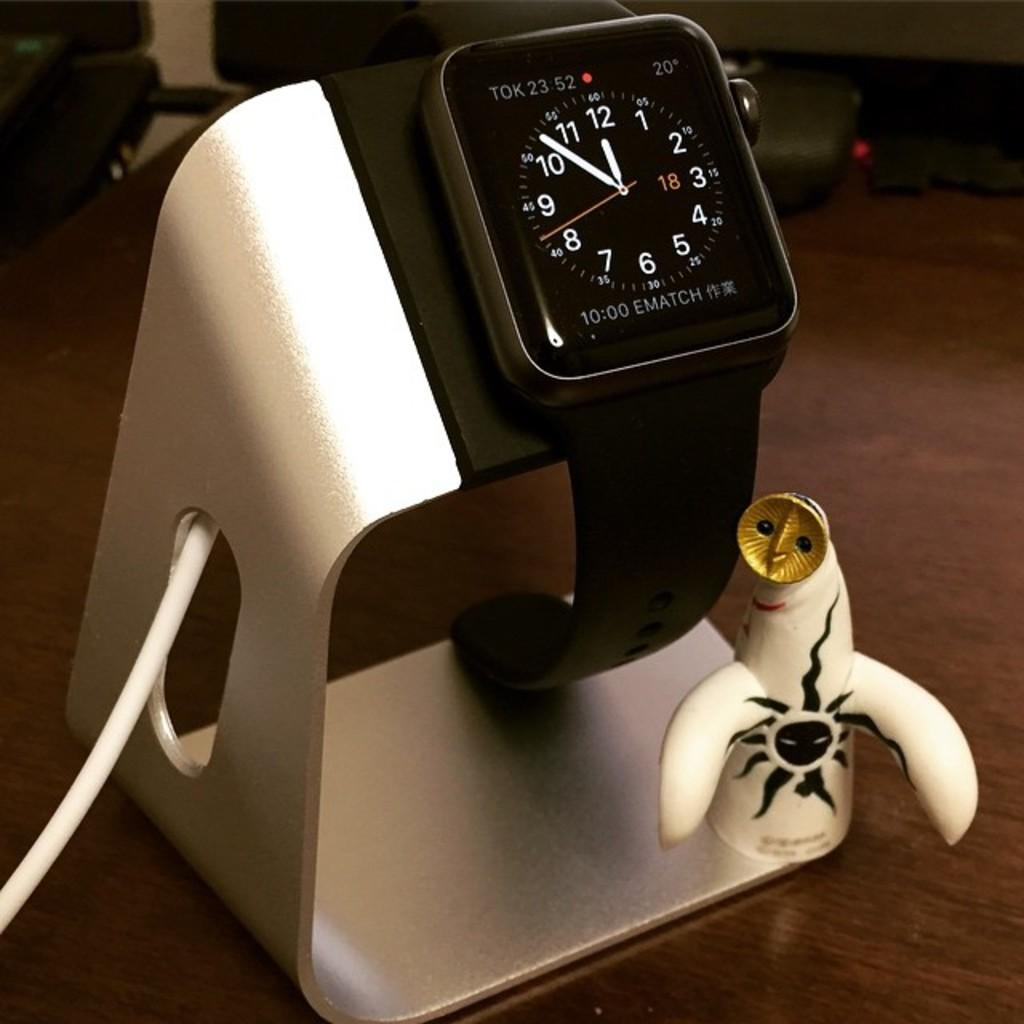<image>
Render a clear and concise summary of the photo. A smart watch on a stand says that today is the 18th. 